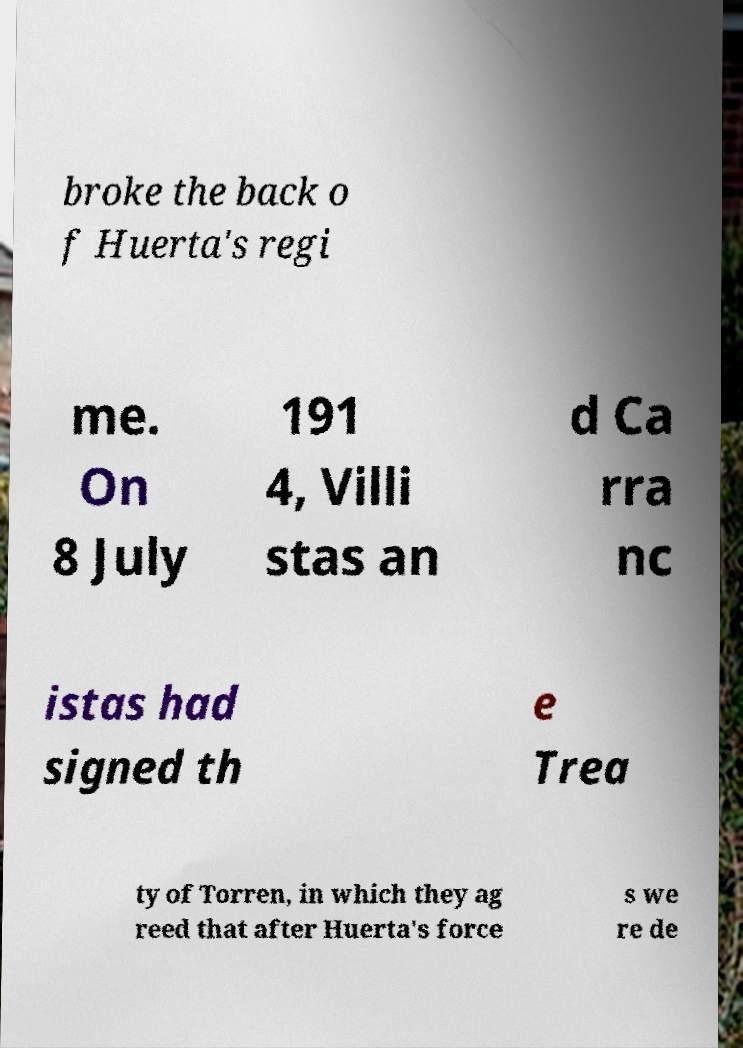Can you accurately transcribe the text from the provided image for me? broke the back o f Huerta's regi me. On 8 July 191 4, Villi stas an d Ca rra nc istas had signed th e Trea ty of Torren, in which they ag reed that after Huerta's force s we re de 